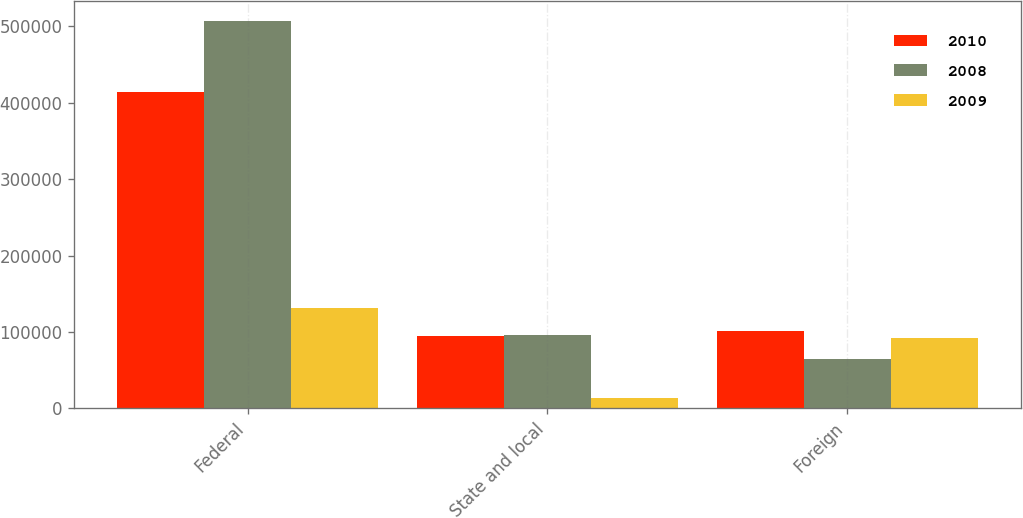<chart> <loc_0><loc_0><loc_500><loc_500><stacked_bar_chart><ecel><fcel>Federal<fcel>State and local<fcel>Foreign<nl><fcel>2010<fcel>414301<fcel>94763<fcel>101662<nl><fcel>2008<fcel>507411<fcel>96496<fcel>64960<nl><fcel>2009<fcel>130962<fcel>13356<fcel>92209<nl></chart> 